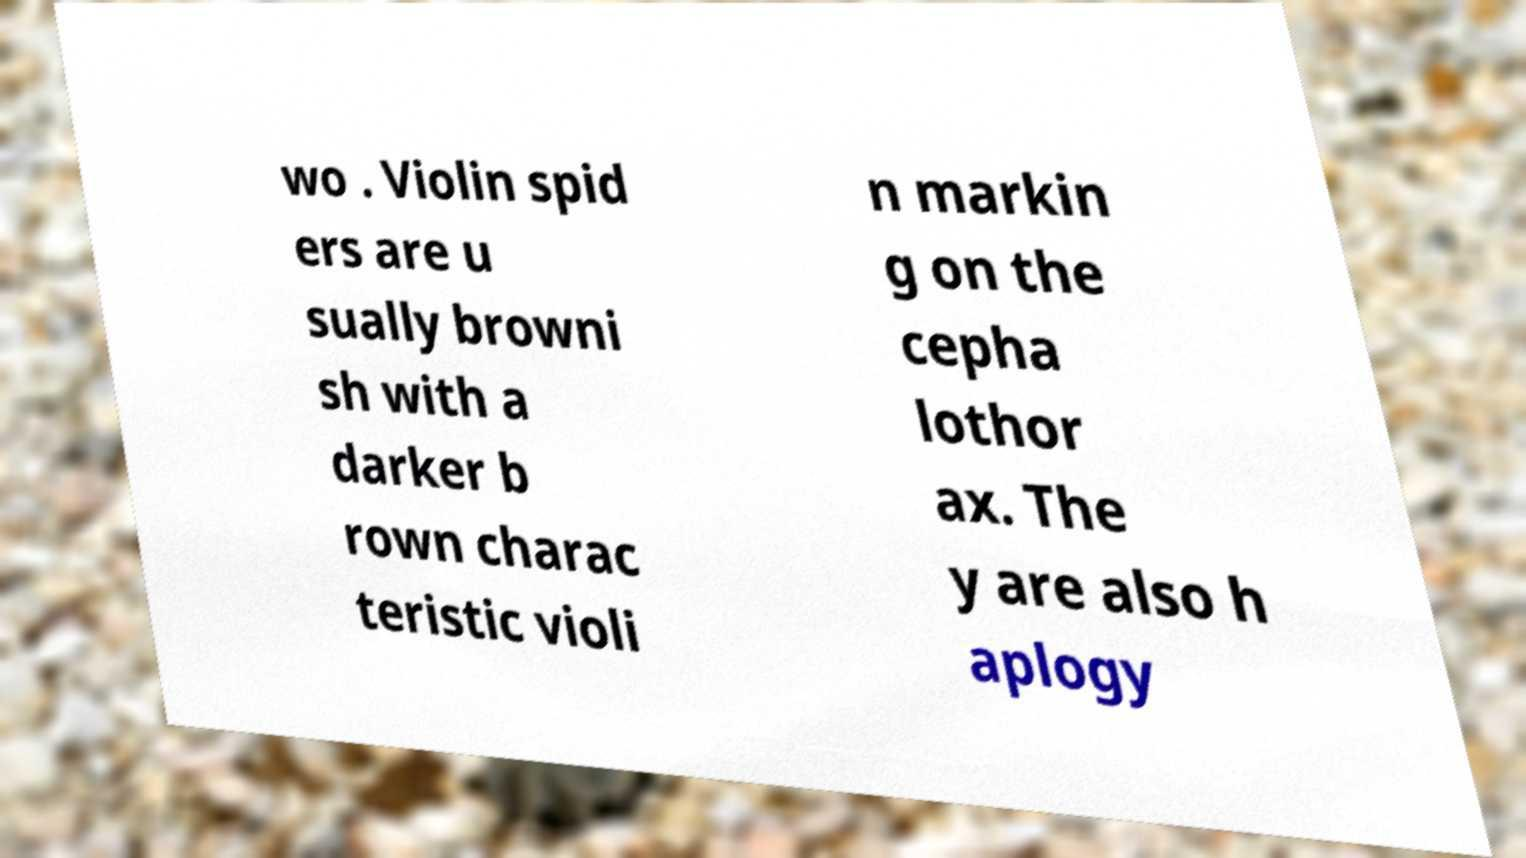What messages or text are displayed in this image? I need them in a readable, typed format. wo . Violin spid ers are u sually browni sh with a darker b rown charac teristic violi n markin g on the cepha lothor ax. The y are also h aplogy 